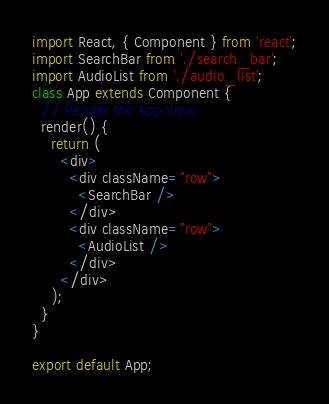<code> <loc_0><loc_0><loc_500><loc_500><_JavaScript_>import React, { Component } from 'react';
import SearchBar from './search_bar';
import AudioList from './audio_list';
class App extends Component {
  // Render the App View
  render() {
    return (
      <div>
        <div className="row">
          <SearchBar />
        </div>
        <div className="row">
          <AudioList />
        </div>
      </div>
    );
  }
}

export default App;
</code> 